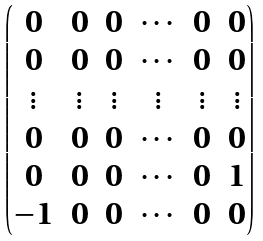Convert formula to latex. <formula><loc_0><loc_0><loc_500><loc_500>\begin{pmatrix} 0 & 0 & 0 & \cdots & 0 & 0 \\ 0 & 0 & 0 & \cdots & 0 & 0 \\ \vdots & \vdots & \vdots & \vdots & \vdots & \vdots \\ 0 & 0 & 0 & \cdots & 0 & 0 \\ 0 & 0 & 0 & \cdots & 0 & 1 \\ - 1 & 0 & 0 & \cdots & 0 & 0 \\ \end{pmatrix}</formula> 